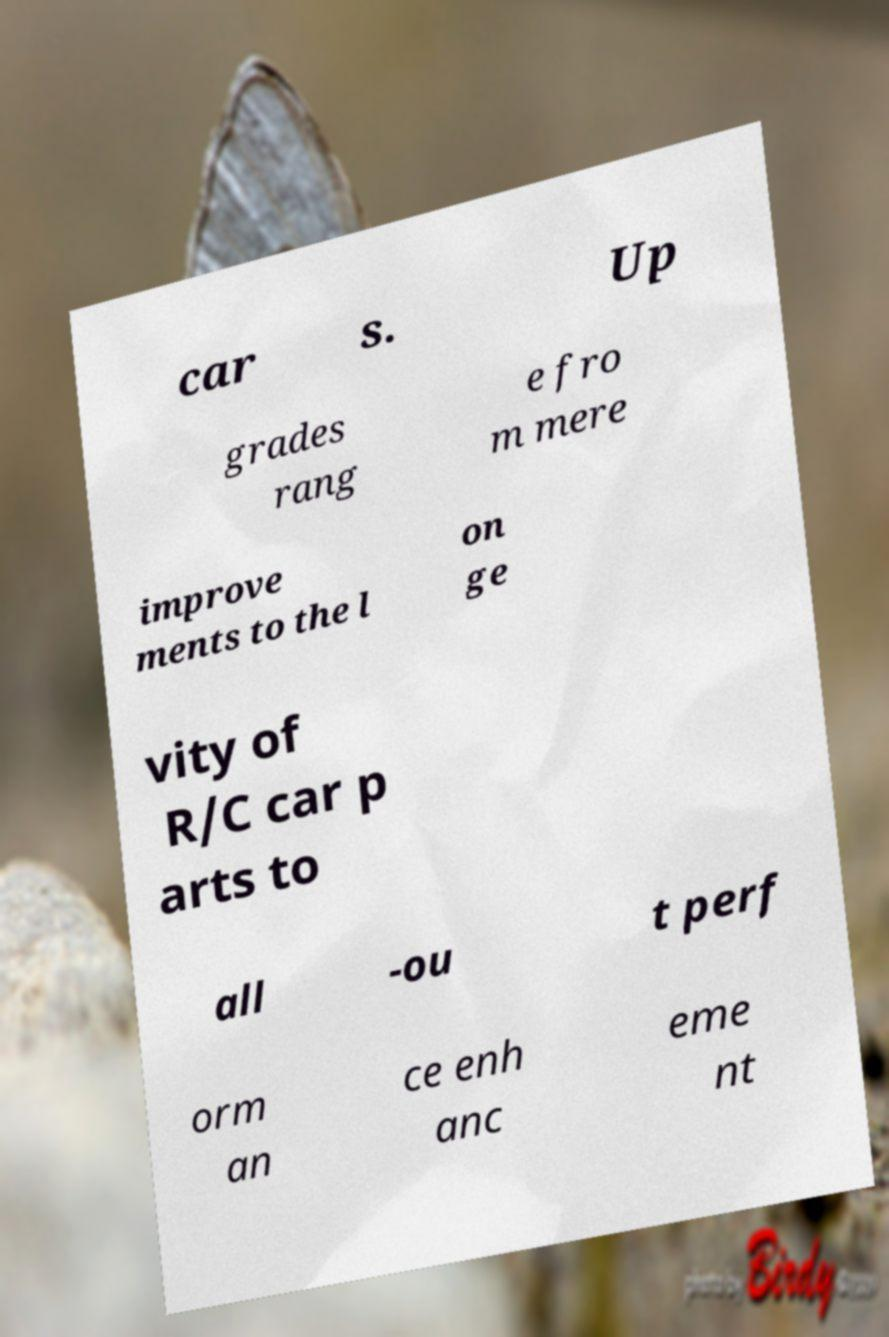What messages or text are displayed in this image? I need them in a readable, typed format. car s. Up grades rang e fro m mere improve ments to the l on ge vity of R/C car p arts to all -ou t perf orm an ce enh anc eme nt 